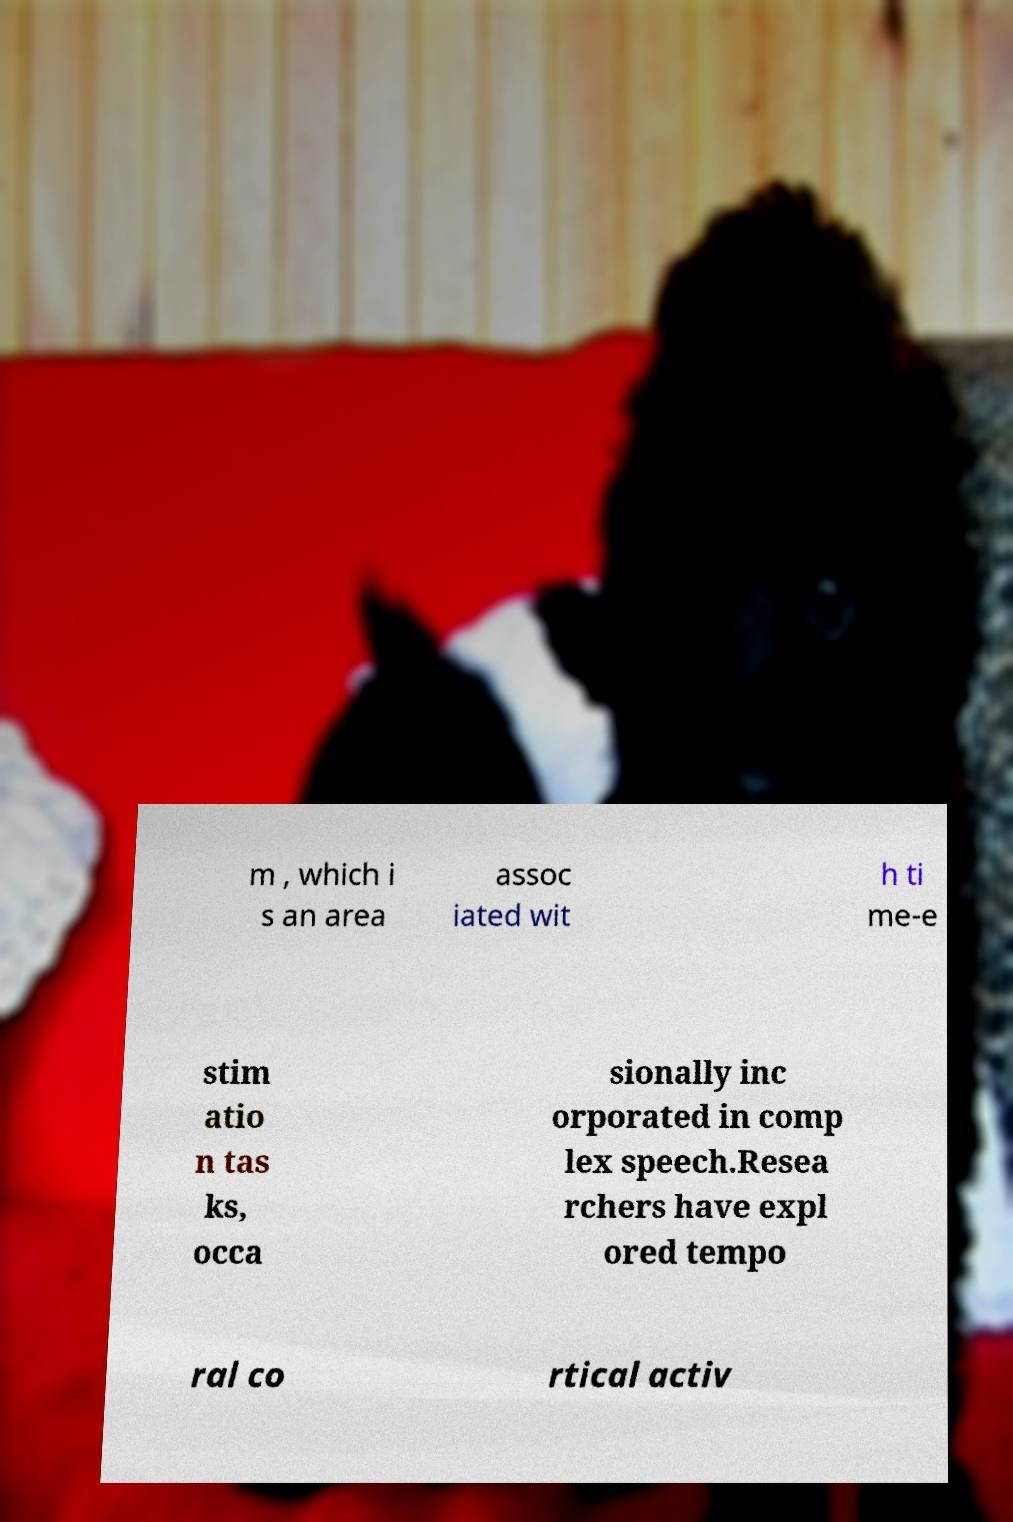Can you accurately transcribe the text from the provided image for me? m , which i s an area assoc iated wit h ti me-e stim atio n tas ks, occa sionally inc orporated in comp lex speech.Resea rchers have expl ored tempo ral co rtical activ 